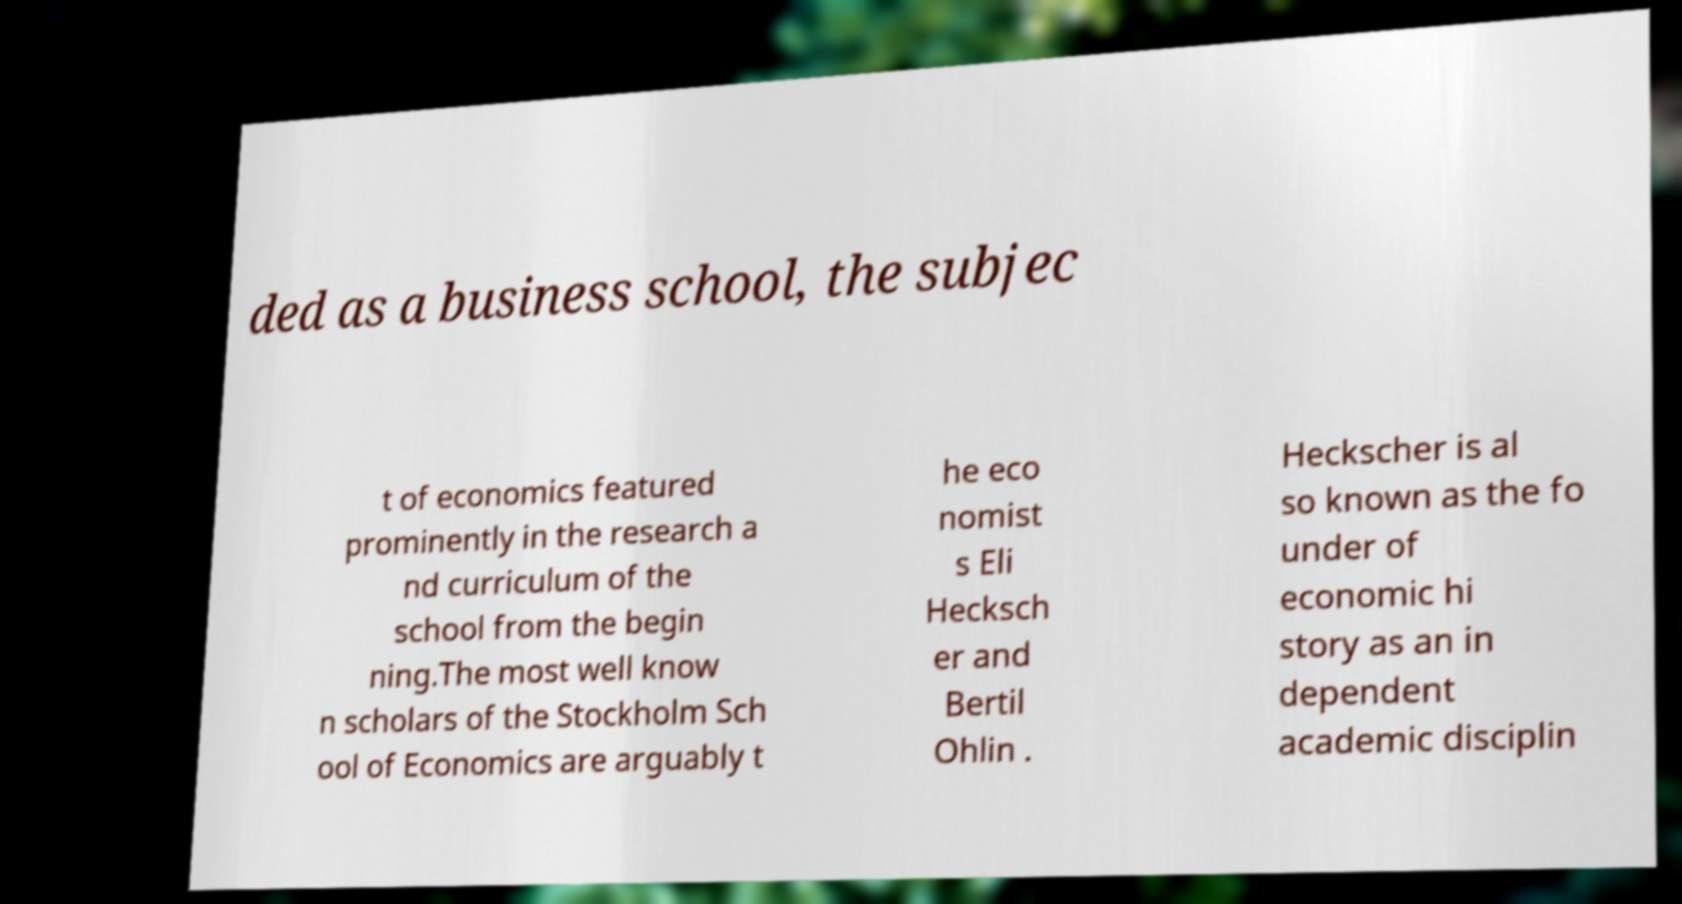Can you read and provide the text displayed in the image?This photo seems to have some interesting text. Can you extract and type it out for me? ded as a business school, the subjec t of economics featured prominently in the research a nd curriculum of the school from the begin ning.The most well know n scholars of the Stockholm Sch ool of Economics are arguably t he eco nomist s Eli Hecksch er and Bertil Ohlin . Heckscher is al so known as the fo under of economic hi story as an in dependent academic disciplin 